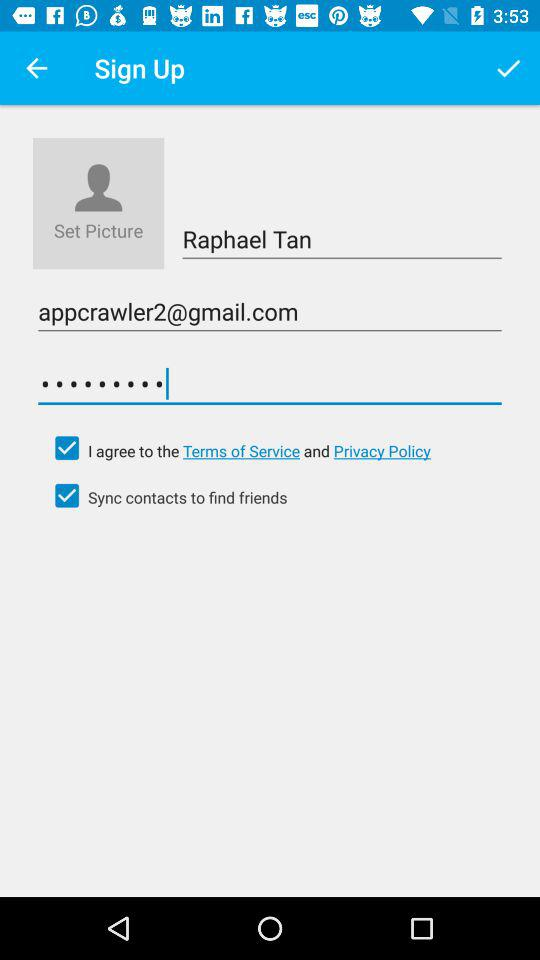What is the status of sync contacts? The status is on. 